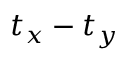Convert formula to latex. <formula><loc_0><loc_0><loc_500><loc_500>t _ { x } - t _ { y }</formula> 